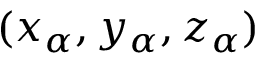Convert formula to latex. <formula><loc_0><loc_0><loc_500><loc_500>( x _ { \alpha } , y _ { \alpha } , z _ { \alpha } )</formula> 